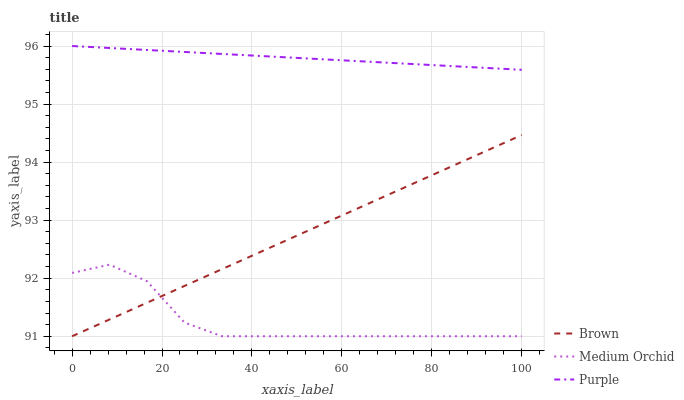Does Medium Orchid have the minimum area under the curve?
Answer yes or no. Yes. Does Purple have the maximum area under the curve?
Answer yes or no. Yes. Does Brown have the minimum area under the curve?
Answer yes or no. No. Does Brown have the maximum area under the curve?
Answer yes or no. No. Is Purple the smoothest?
Answer yes or no. Yes. Is Medium Orchid the roughest?
Answer yes or no. Yes. Is Brown the smoothest?
Answer yes or no. No. Is Brown the roughest?
Answer yes or no. No. Does Brown have the lowest value?
Answer yes or no. Yes. Does Purple have the highest value?
Answer yes or no. Yes. Does Brown have the highest value?
Answer yes or no. No. Is Medium Orchid less than Purple?
Answer yes or no. Yes. Is Purple greater than Medium Orchid?
Answer yes or no. Yes. Does Medium Orchid intersect Brown?
Answer yes or no. Yes. Is Medium Orchid less than Brown?
Answer yes or no. No. Is Medium Orchid greater than Brown?
Answer yes or no. No. Does Medium Orchid intersect Purple?
Answer yes or no. No. 